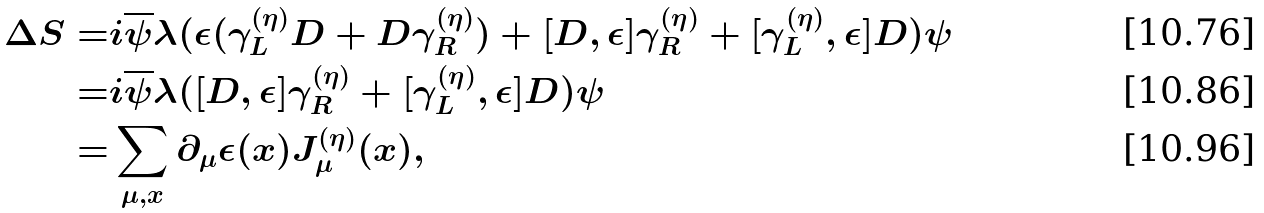Convert formula to latex. <formula><loc_0><loc_0><loc_500><loc_500>\Delta S = & i \overline { \psi } \lambda ( \epsilon ( \gamma _ { L } ^ { ( \eta ) } D + D \gamma _ { R } ^ { ( \eta ) } ) + [ D , \epsilon ] \gamma _ { R } ^ { ( \eta ) } + [ \gamma _ { L } ^ { ( \eta ) } , \epsilon ] D ) \psi \\ = & i \overline { \psi } \lambda ( [ D , \epsilon ] \gamma _ { R } ^ { ( \eta ) } + [ \gamma _ { L } ^ { ( \eta ) } , \epsilon ] D ) \psi \\ = & \sum _ { \mu , x } \partial _ { \mu } \epsilon ( x ) J ^ { ( \eta ) } _ { \mu } ( x ) ,</formula> 